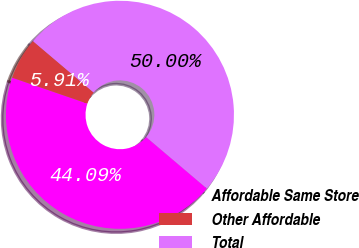Convert chart. <chart><loc_0><loc_0><loc_500><loc_500><pie_chart><fcel>Affordable Same Store<fcel>Other Affordable<fcel>Total<nl><fcel>44.09%<fcel>5.91%<fcel>50.0%<nl></chart> 